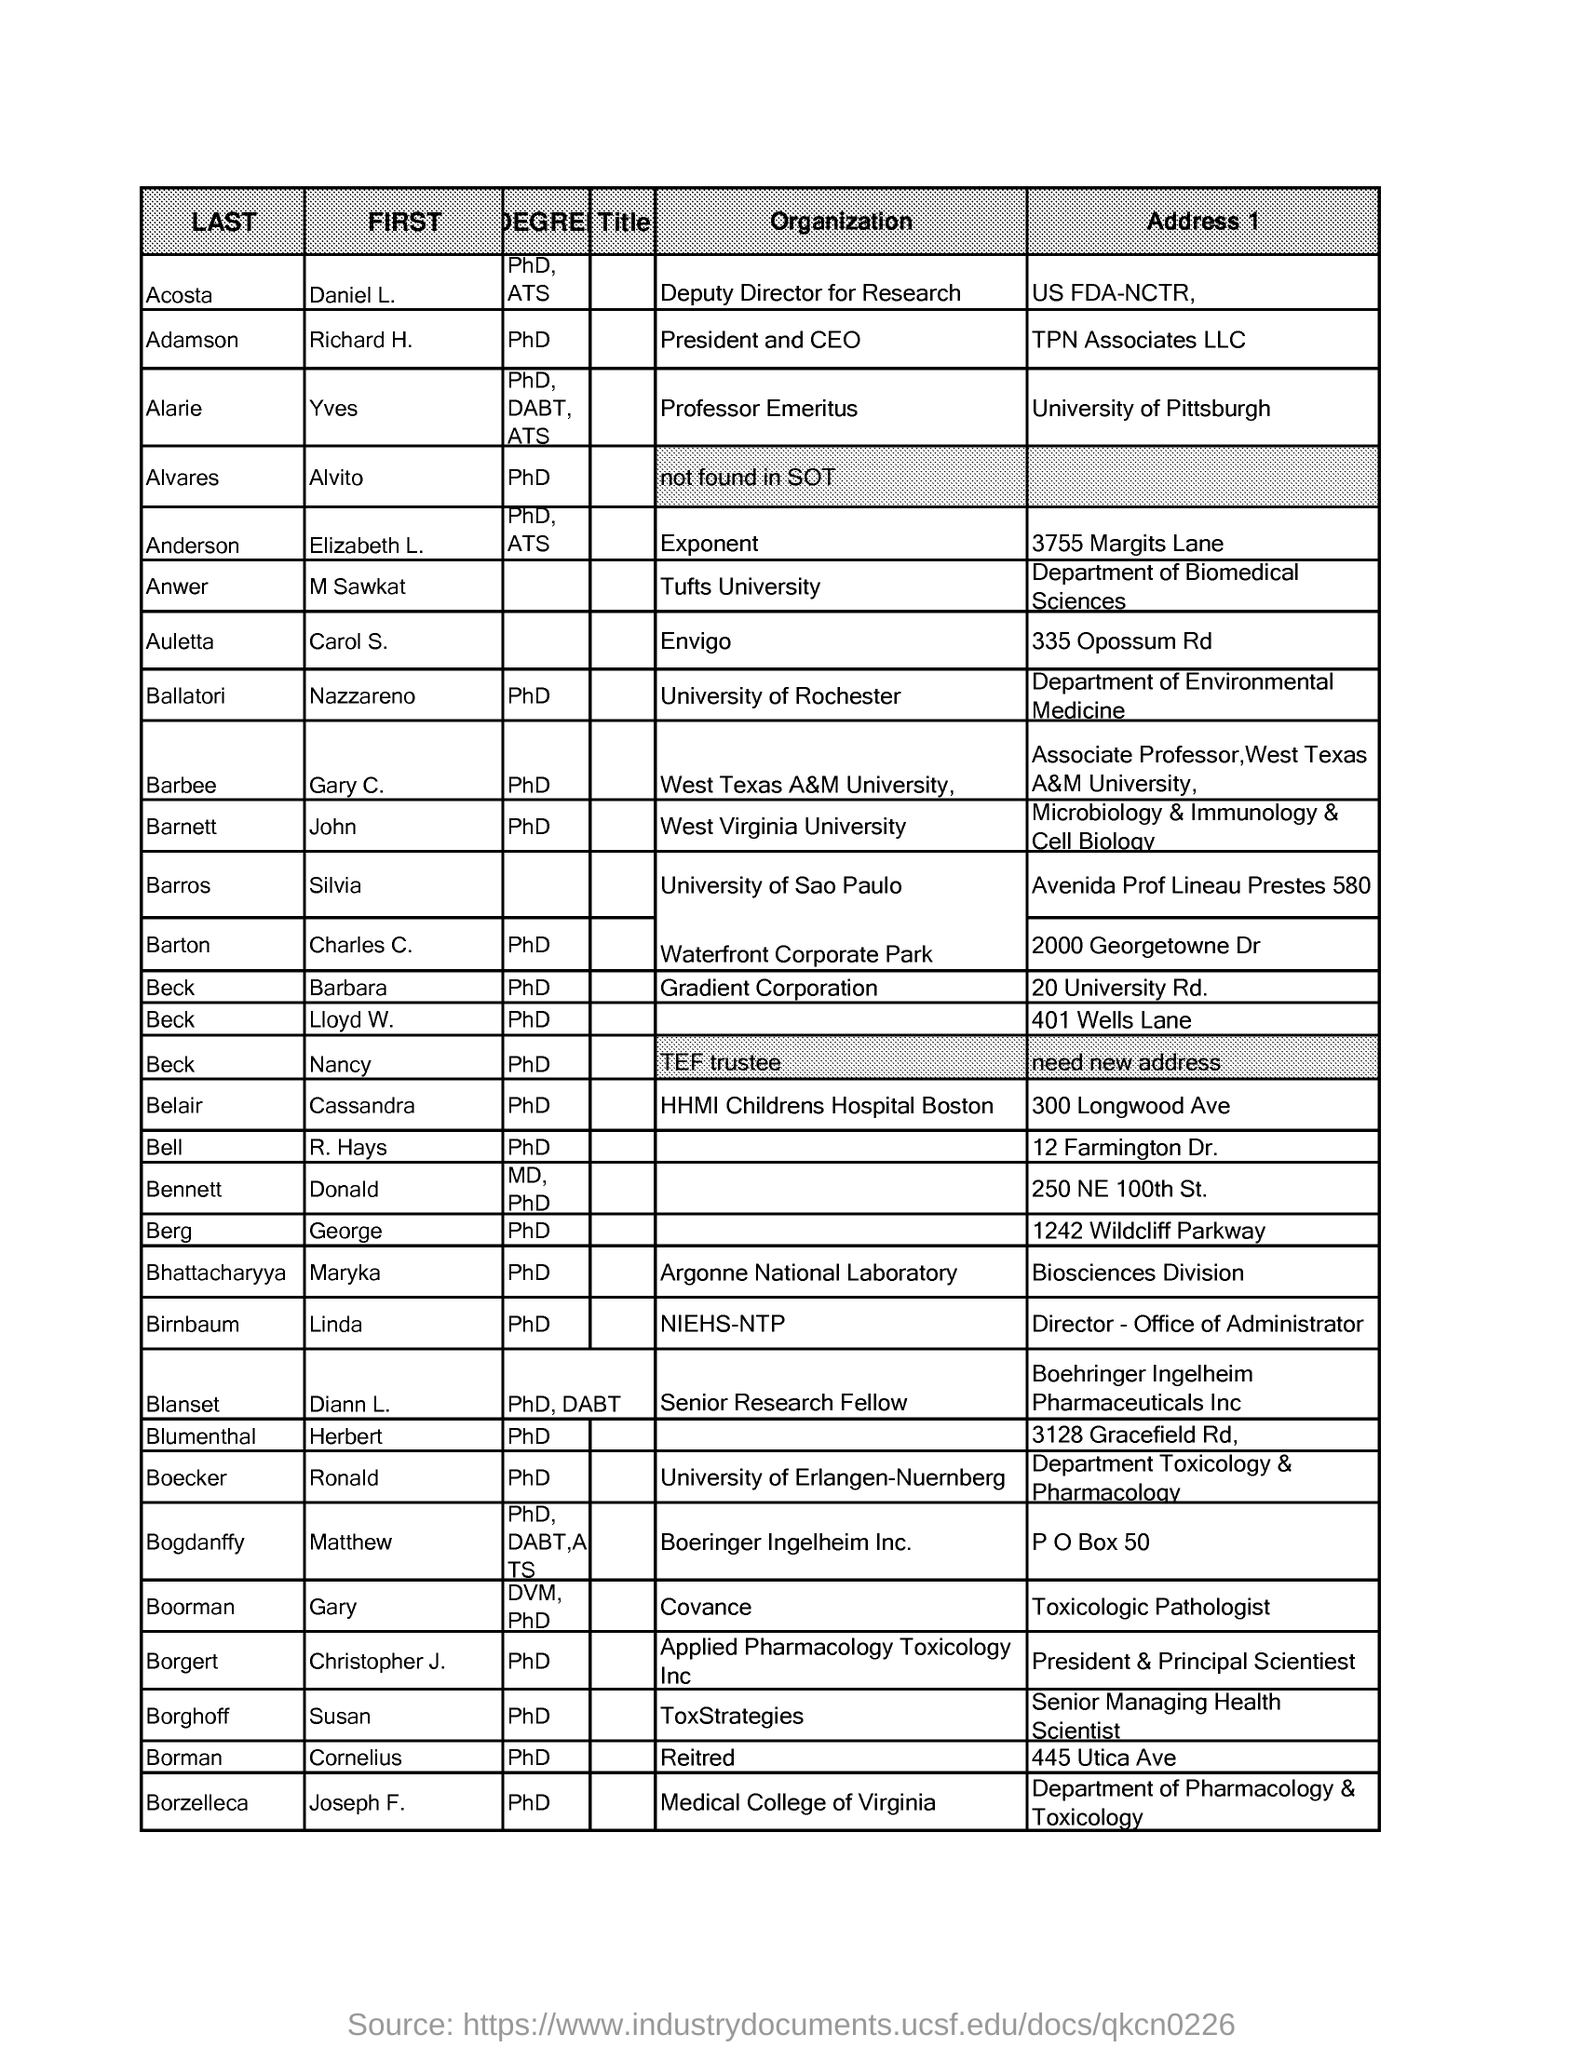Outline some significant characteristics in this image. Daniel L. Acosta holds the designation of Deputy Director for Research. The address 1 of Daniel L. Acosta is located at the US FDA-NCTR. Diann L. Blanset holds the designation of Senior Research Fellow. Diann L. Blanset holds a PhD degree, which is the highest educational degree that she has obtained. M Sawkat Anwer works at Tufts University. 